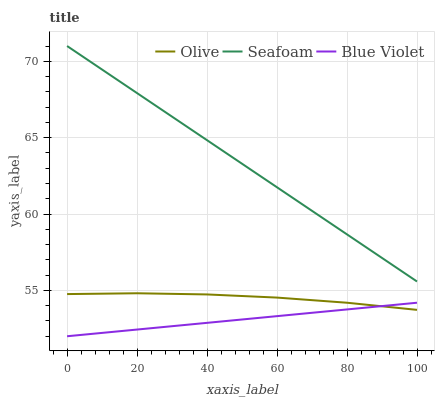Does Blue Violet have the minimum area under the curve?
Answer yes or no. Yes. Does Seafoam have the maximum area under the curve?
Answer yes or no. Yes. Does Seafoam have the minimum area under the curve?
Answer yes or no. No. Does Blue Violet have the maximum area under the curve?
Answer yes or no. No. Is Blue Violet the smoothest?
Answer yes or no. Yes. Is Olive the roughest?
Answer yes or no. Yes. Is Seafoam the smoothest?
Answer yes or no. No. Is Seafoam the roughest?
Answer yes or no. No. Does Seafoam have the lowest value?
Answer yes or no. No. Does Seafoam have the highest value?
Answer yes or no. Yes. Does Blue Violet have the highest value?
Answer yes or no. No. Is Blue Violet less than Seafoam?
Answer yes or no. Yes. Is Seafoam greater than Blue Violet?
Answer yes or no. Yes. Does Olive intersect Blue Violet?
Answer yes or no. Yes. Is Olive less than Blue Violet?
Answer yes or no. No. Is Olive greater than Blue Violet?
Answer yes or no. No. Does Blue Violet intersect Seafoam?
Answer yes or no. No. 